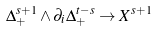Convert formula to latex. <formula><loc_0><loc_0><loc_500><loc_500>\Delta ^ { s + 1 } _ { + } \wedge \partial _ { i } \Delta ^ { t - s } _ { + } \rightarrow X ^ { s + 1 }</formula> 